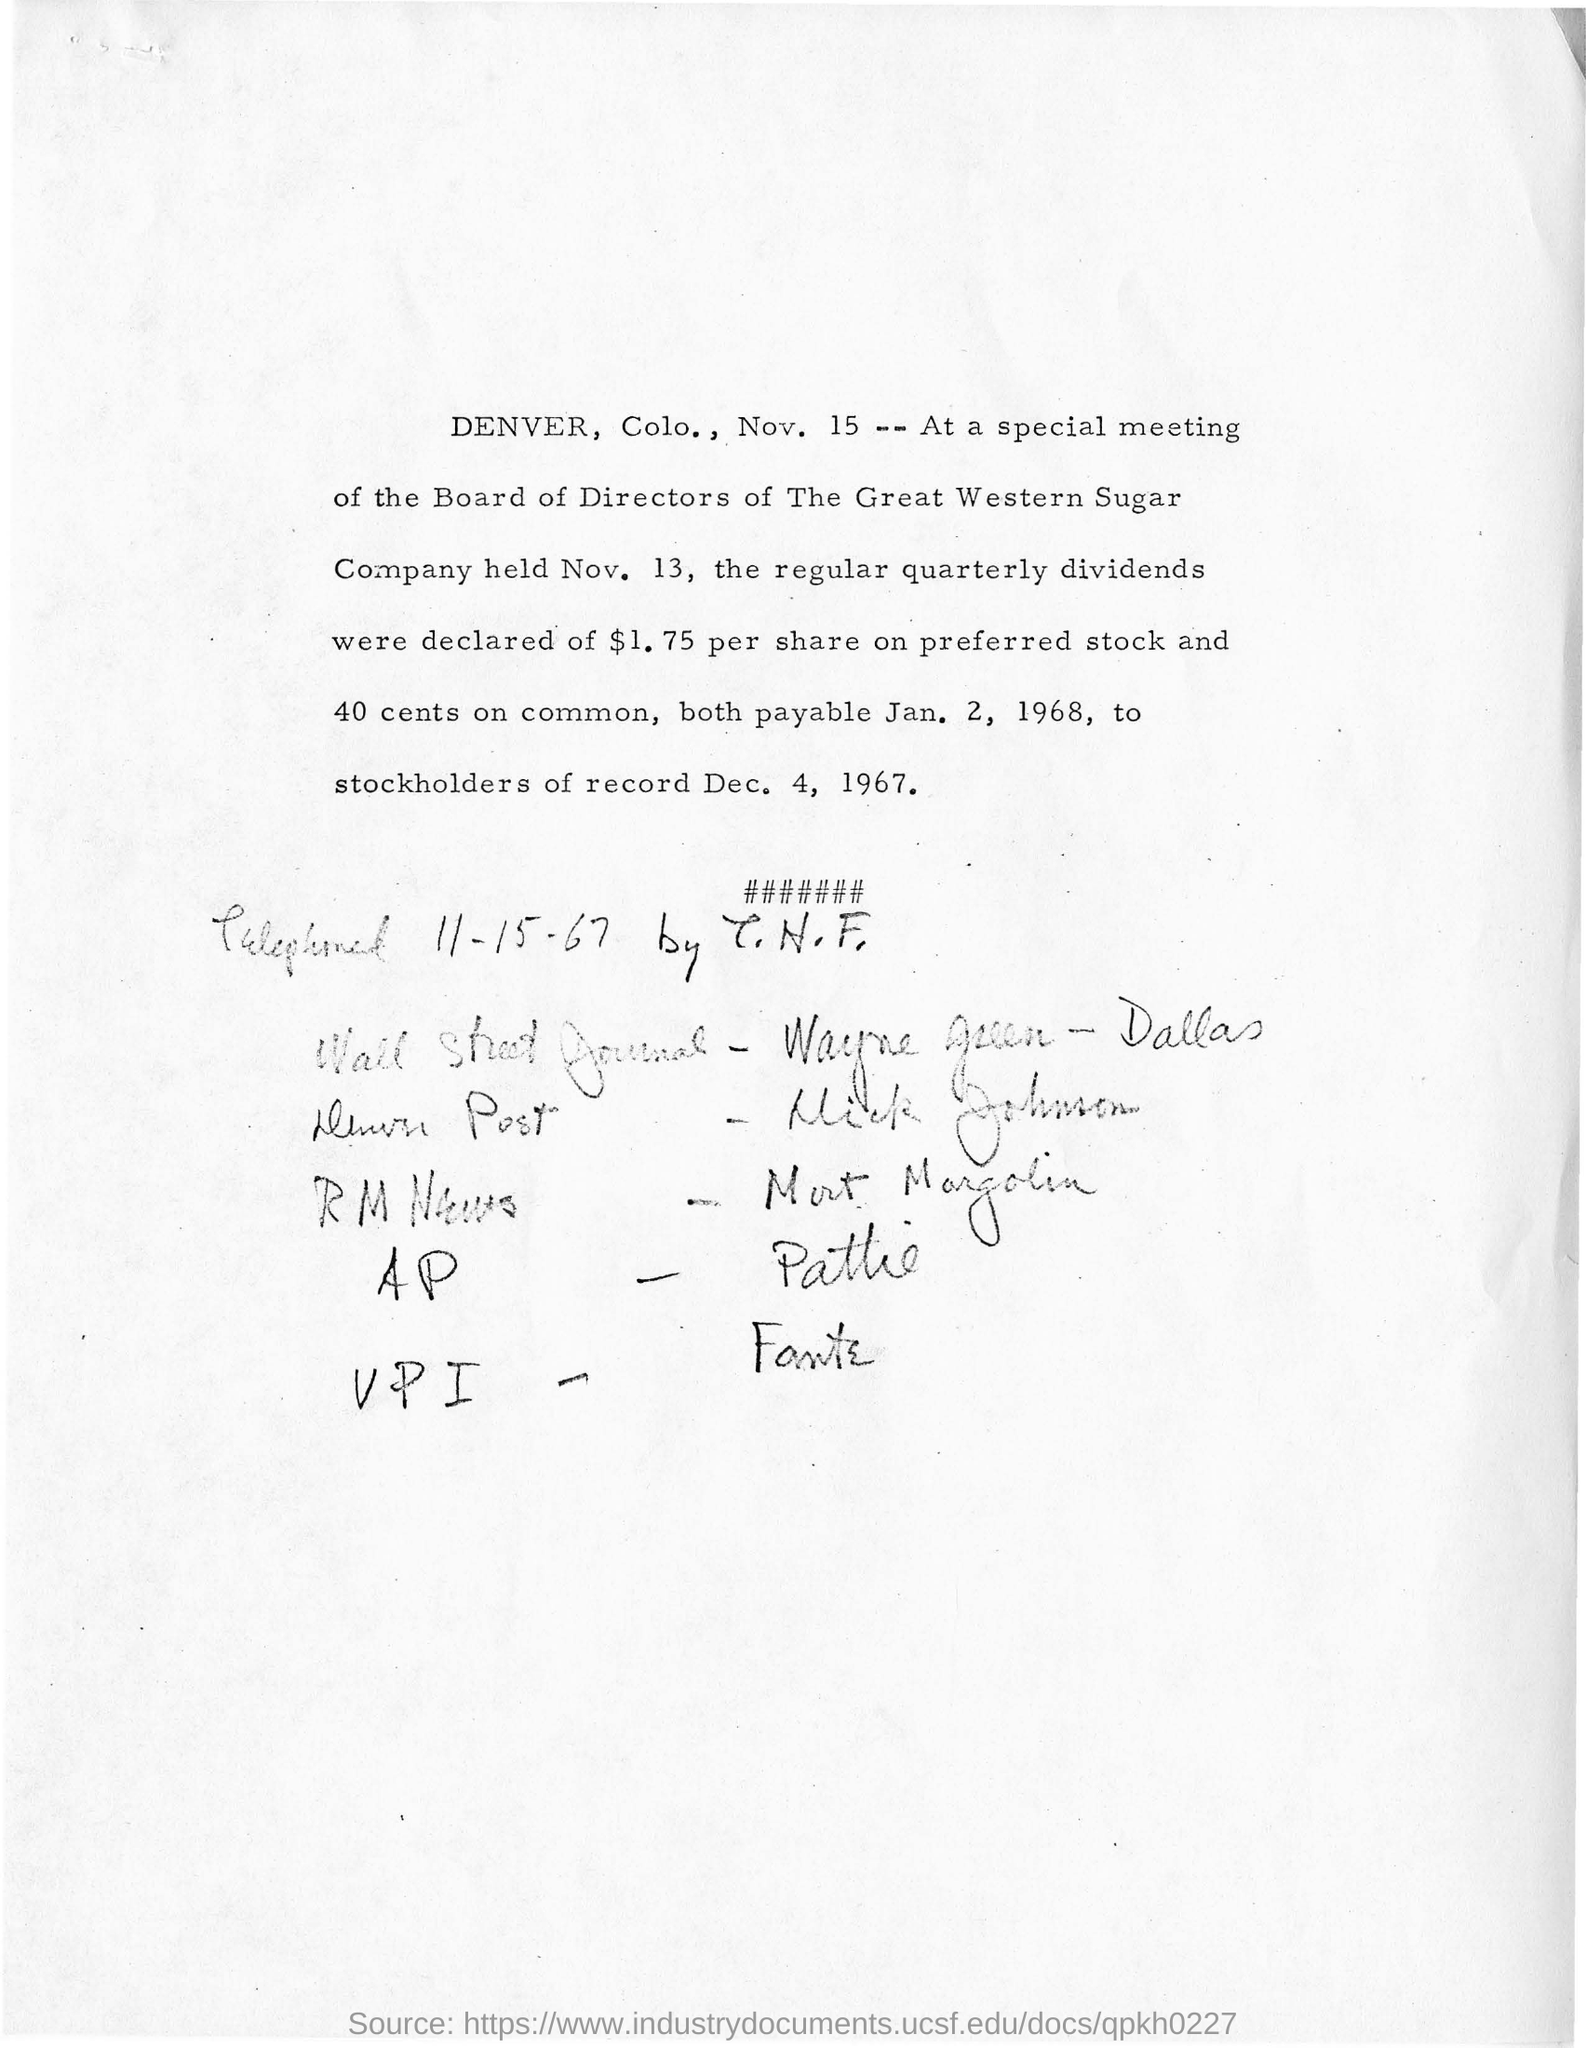Where is this special meeting held?
Your response must be concise. DENVER, Colo. Which company are the Board of directors from?
Ensure brevity in your answer.  The Great Western Sugar Company. When is the special meeting held?
Offer a very short reply. Nov. 13. How many dollars per share were declared on preferred stock?
Make the answer very short. $1.75. 